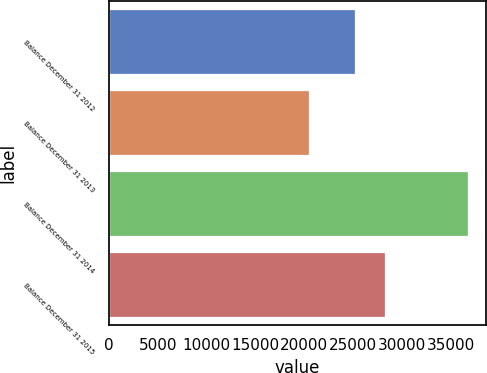<chart> <loc_0><loc_0><loc_500><loc_500><bar_chart><fcel>Balance December 31 2012<fcel>Balance December 31 2013<fcel>Balance December 31 2014<fcel>Balance December 31 2015<nl><fcel>25151<fcel>20494<fcel>36764<fcel>28240<nl></chart> 